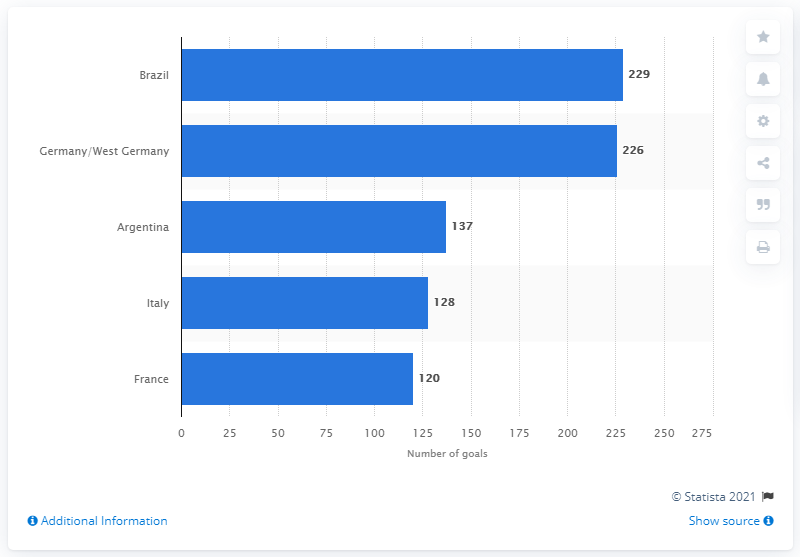Give some essential details in this illustration. At the 2018 FIFA World Cup, Brazil scored 229 goals. 